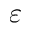Convert formula to latex. <formula><loc_0><loc_0><loc_500><loc_500>\varepsilon</formula> 